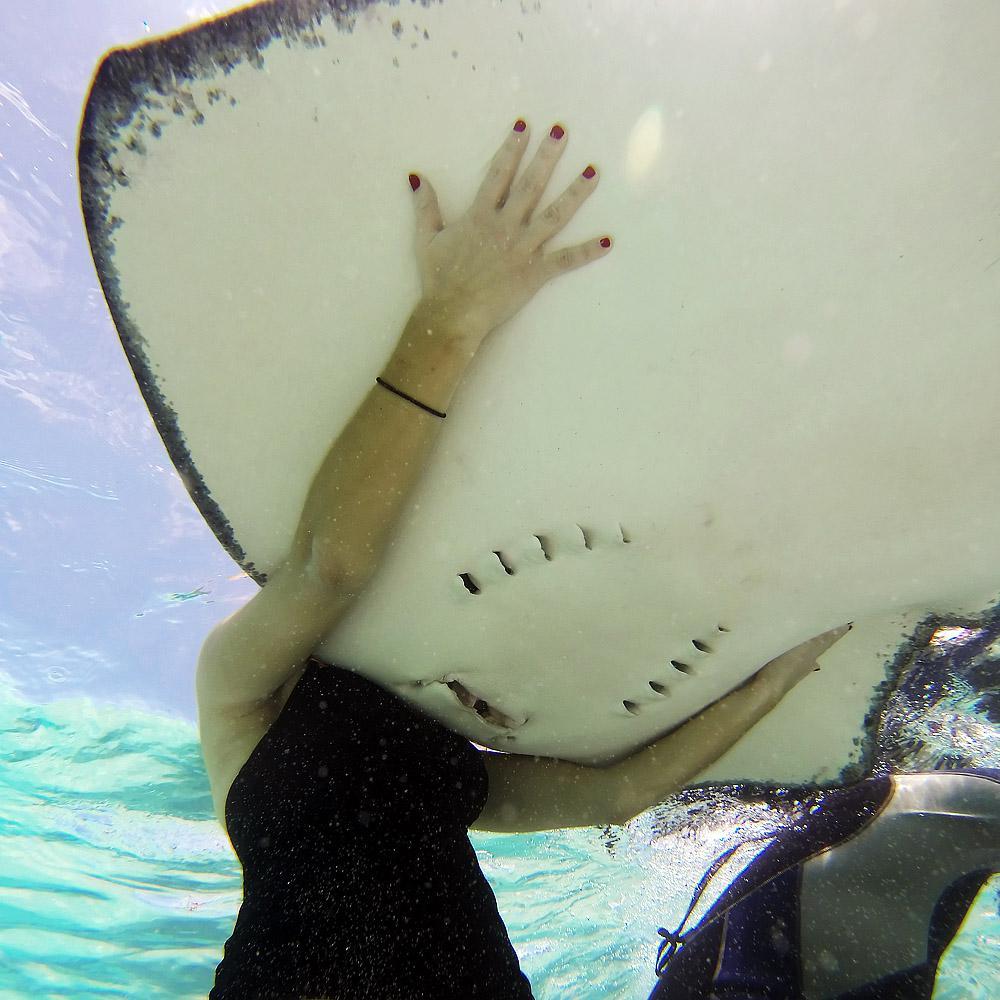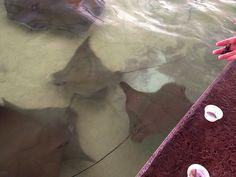The first image is the image on the left, the second image is the image on the right. Considering the images on both sides, is "An image shows one dark stingray with small pale dots." valid? Answer yes or no. No. 